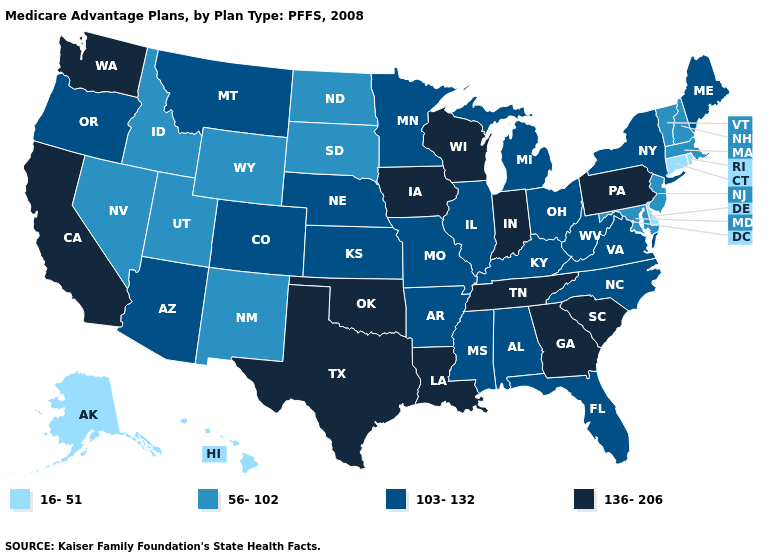What is the highest value in states that border Vermont?
Short answer required. 103-132. Name the states that have a value in the range 103-132?
Keep it brief. Alabama, Arkansas, Arizona, Colorado, Florida, Illinois, Kansas, Kentucky, Maine, Michigan, Minnesota, Missouri, Mississippi, Montana, North Carolina, Nebraska, New York, Ohio, Oregon, Virginia, West Virginia. What is the highest value in the USA?
Short answer required. 136-206. Name the states that have a value in the range 136-206?
Quick response, please. California, Georgia, Iowa, Indiana, Louisiana, Oklahoma, Pennsylvania, South Carolina, Tennessee, Texas, Washington, Wisconsin. Does the first symbol in the legend represent the smallest category?
Answer briefly. Yes. Name the states that have a value in the range 56-102?
Answer briefly. Idaho, Massachusetts, Maryland, North Dakota, New Hampshire, New Jersey, New Mexico, Nevada, South Dakota, Utah, Vermont, Wyoming. Does the first symbol in the legend represent the smallest category?
Write a very short answer. Yes. Does Vermont have a lower value than New Jersey?
Concise answer only. No. Is the legend a continuous bar?
Give a very brief answer. No. What is the value of Maryland?
Keep it brief. 56-102. What is the value of Mississippi?
Answer briefly. 103-132. How many symbols are there in the legend?
Be succinct. 4. Name the states that have a value in the range 16-51?
Give a very brief answer. Alaska, Connecticut, Delaware, Hawaii, Rhode Island. Name the states that have a value in the range 56-102?
Be succinct. Idaho, Massachusetts, Maryland, North Dakota, New Hampshire, New Jersey, New Mexico, Nevada, South Dakota, Utah, Vermont, Wyoming. What is the highest value in the USA?
Quick response, please. 136-206. 